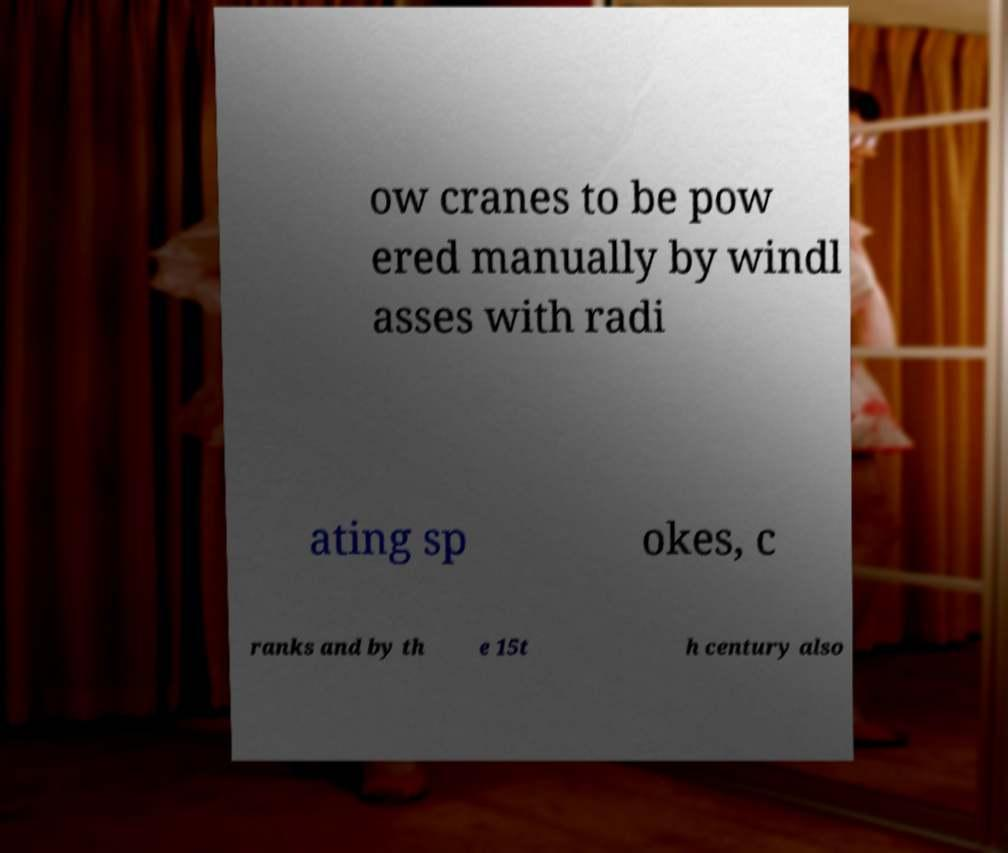Please read and relay the text visible in this image. What does it say? ow cranes to be pow ered manually by windl asses with radi ating sp okes, c ranks and by th e 15t h century also 